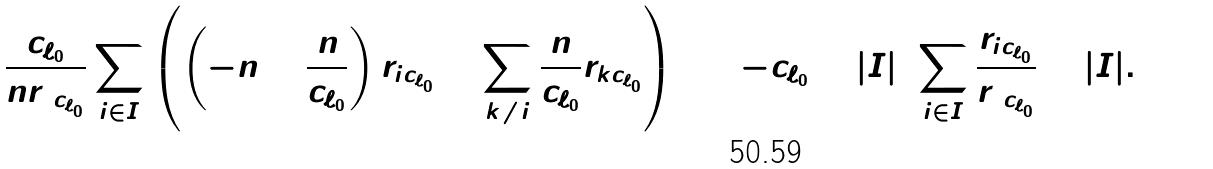<formula> <loc_0><loc_0><loc_500><loc_500>0 = \frac { c _ { \ell _ { 0 } } } { n r _ { 0 c _ { \ell _ { 0 } } } } \sum _ { i \in I } \left ( \left ( - n + \frac { n } { c _ { \ell _ { 0 } } } \right ) r _ { i c _ { \ell _ { 0 } } } + \sum _ { k \neq i } \frac { n } { c _ { \ell _ { 0 } } } r _ { k c _ { \ell _ { 0 } } } \right ) = ( - c _ { \ell _ { 0 } } + | I | ) \sum _ { i \in I } \frac { r _ { i c _ { \ell _ { 0 } } } } { r _ { 0 c _ { \ell _ { 0 } } } } + | I | .</formula> 